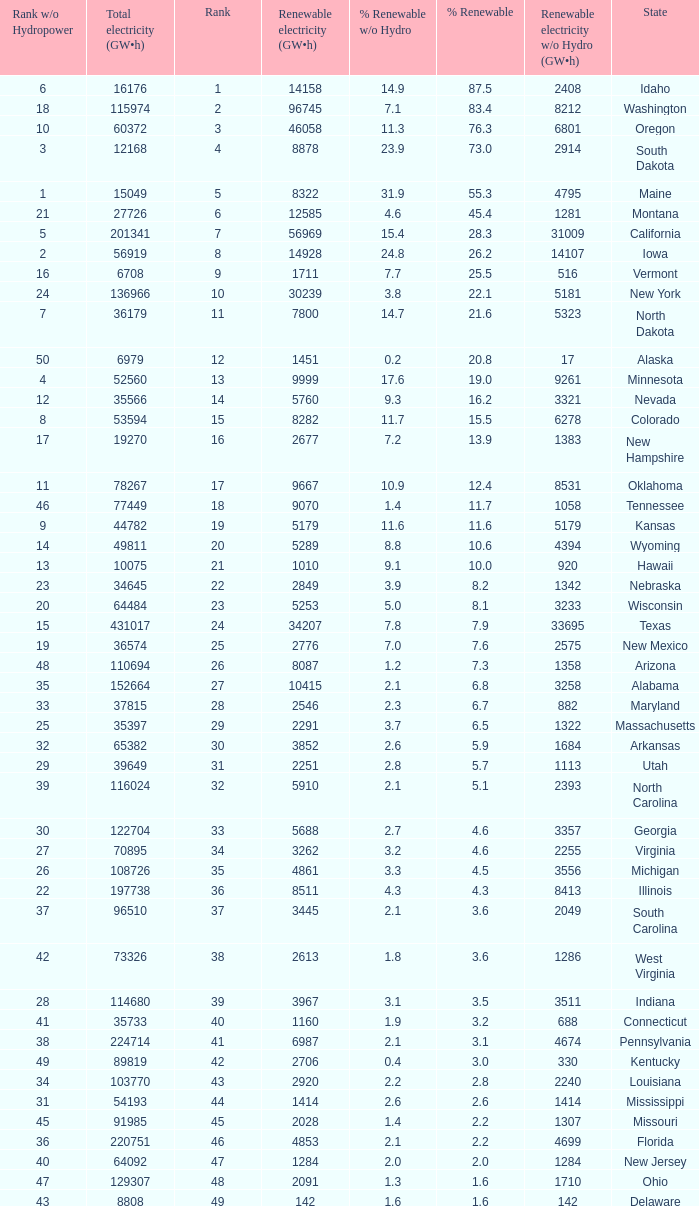Which states have renewable electricity equal to 9667 (gw×h)? Oklahoma. 